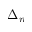Convert formula to latex. <formula><loc_0><loc_0><loc_500><loc_500>\Delta _ { n }</formula> 